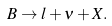<formula> <loc_0><loc_0><loc_500><loc_500>B \rightarrow l + \nu + X .</formula> 